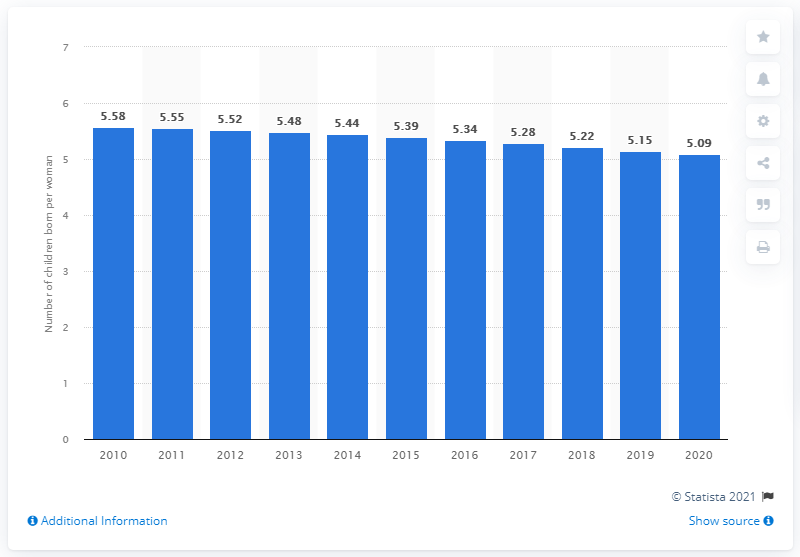Specify some key components in this picture. The fertility rate in the Gambia was 5.09 in 2020. 